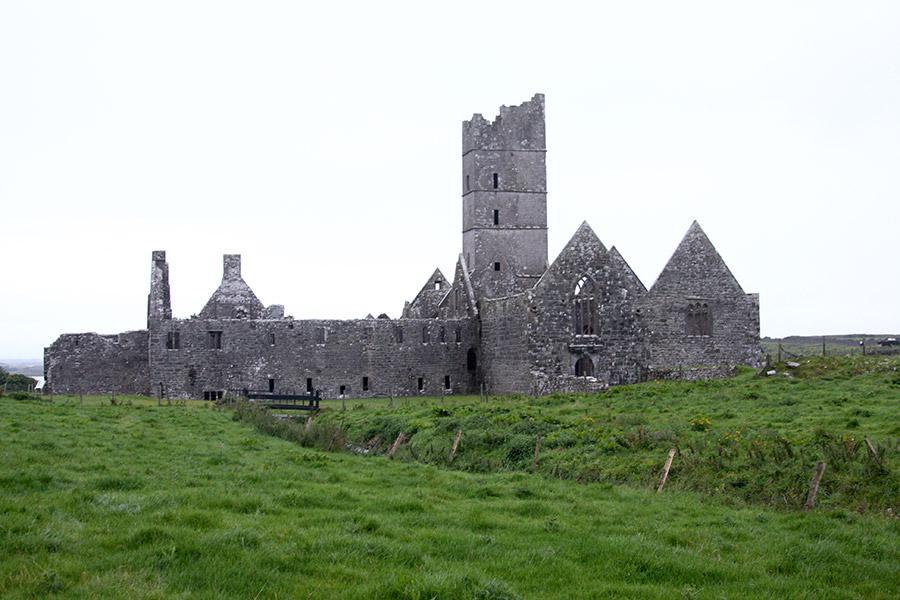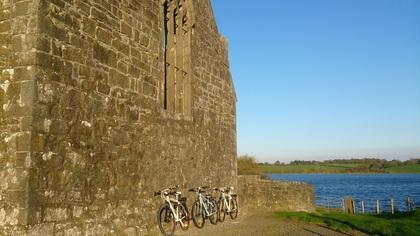The first image is the image on the left, the second image is the image on the right. Assess this claim about the two images: "There is a castle with a broken tower in the image on the left.". Correct or not? Answer yes or no. Yes. 